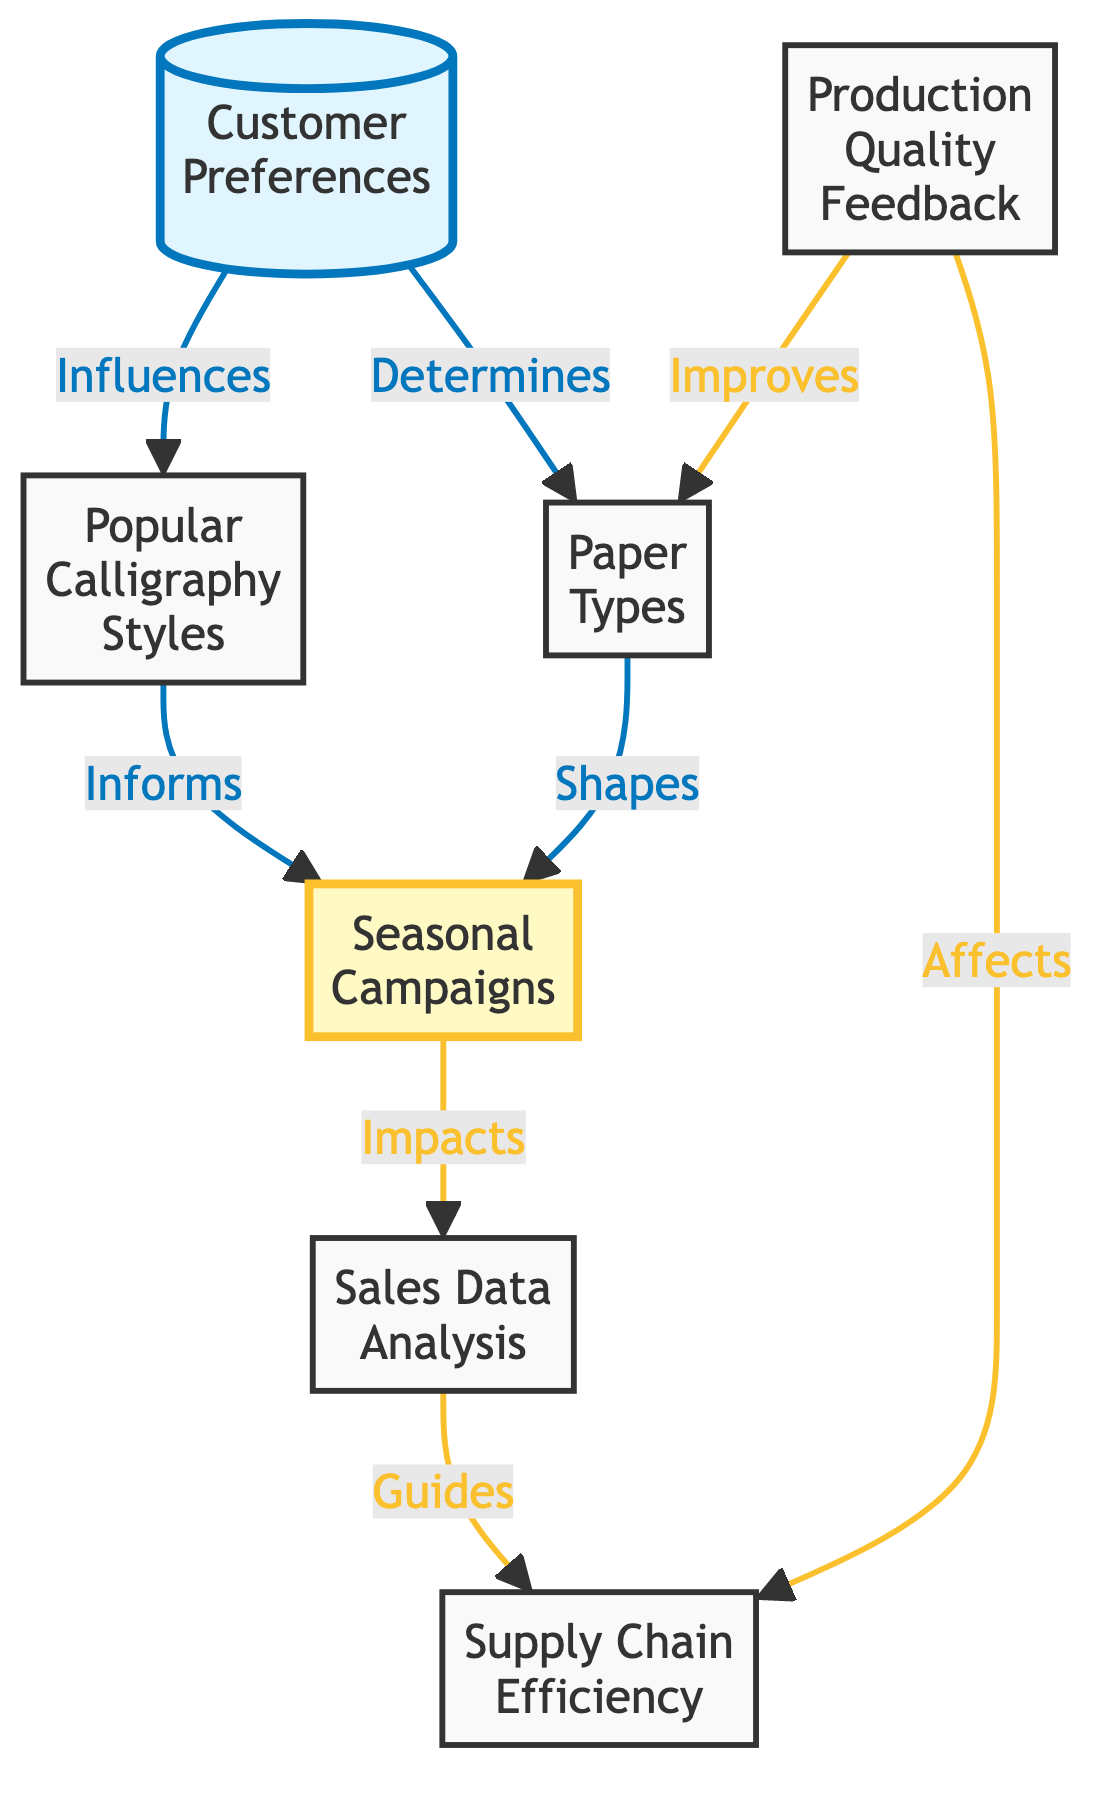What is the first node in the flowchart? The first node is "Customer Preferences" which is clearly identified at the top of the flowchart.
Answer: Customer Preferences How many nodes are in the flowchart? Counting all the distinct elements represented, there are a total of 7 nodes in the flowchart.
Answer: 7 What relationship is indicated between "Customer Preferences" and "Popular Calligraphy Styles"? The flowchart shows that "Customer Preferences" influences "Popular Calligraphy Styles," as indicated by the arrow direction connecting the two.
Answer: Influences Which node receives feedback to improve its quality? The "Production Quality Feedback" node contributes to improving the "Paper Types" node, as shown by the arrow linked from feedback to paper types.
Answer: Paper Types What impact does "Seasonal Campaigns" have on sales? The flowchart explicitly states that "Seasonal Campaigns" impacts "Sales Data Analysis," meaning that effective campaigns can directly influence sales performance.
Answer: Impacts Which nodes connect to the "Supply Chain Efficiency" node? The "Supply Chain Efficiency" node is connected to both "Sales Data Analysis" and "Production Quality Feedback," indicating that it relies on insights from these areas for efficiency.
Answer: Sales Data Analysis, Production Quality Feedback What is the relationship between "Paper Types" and "Seasonal Campaigns"? "Paper Types" shapes "Seasonal Campaigns" in the flowchart, showing that the choices in paper types directly inform marketing strategies for each season.
Answer: Shapes How does customer preference influence paper types? The diagram indicates that "Customer Preferences" determines the types of paper favored, meaning that customer choices dictate the preferred paper types.
Answer: Determines What role does "Sales Data Analysis" play within the flowchart? "Sales Data Analysis" guides "Supply Chain Efficiency," indicating that insights from sales trends help manage the supply chain logistics.
Answer: Guides 